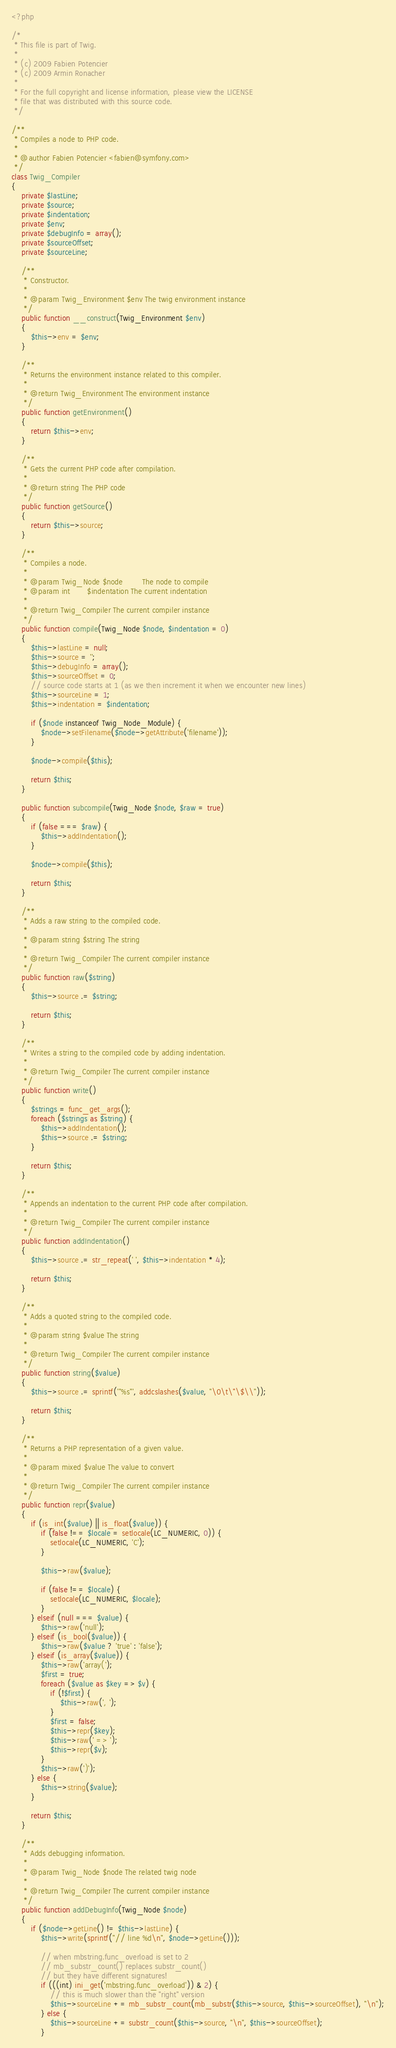<code> <loc_0><loc_0><loc_500><loc_500><_PHP_><?php

/*
 * This file is part of Twig.
 *
 * (c) 2009 Fabien Potencier
 * (c) 2009 Armin Ronacher
 *
 * For the full copyright and license information, please view the LICENSE
 * file that was distributed with this source code.
 */

/**
 * Compiles a node to PHP code.
 *
 * @author Fabien Potencier <fabien@symfony.com>
 */
class Twig_Compiler
{
    private $lastLine;
    private $source;
    private $indentation;
    private $env;
    private $debugInfo = array();
    private $sourceOffset;
    private $sourceLine;

    /**
     * Constructor.
     *
     * @param Twig_Environment $env The twig environment instance
     */
    public function __construct(Twig_Environment $env)
    {
        $this->env = $env;
    }

    /**
     * Returns the environment instance related to this compiler.
     *
     * @return Twig_Environment The environment instance
     */
    public function getEnvironment()
    {
        return $this->env;
    }

    /**
     * Gets the current PHP code after compilation.
     *
     * @return string The PHP code
     */
    public function getSource()
    {
        return $this->source;
    }

    /**
     * Compiles a node.
     *
     * @param Twig_Node $node        The node to compile
     * @param int       $indentation The current indentation
     *
     * @return Twig_Compiler The current compiler instance
     */
    public function compile(Twig_Node $node, $indentation = 0)
    {
        $this->lastLine = null;
        $this->source = '';
        $this->debugInfo = array();
        $this->sourceOffset = 0;
        // source code starts at 1 (as we then increment it when we encounter new lines)
        $this->sourceLine = 1;
        $this->indentation = $indentation;

        if ($node instanceof Twig_Node_Module) {
            $node->setFilename($node->getAttribute('filename'));
        }

        $node->compile($this);

        return $this;
    }

    public function subcompile(Twig_Node $node, $raw = true)
    {
        if (false === $raw) {
            $this->addIndentation();
        }

        $node->compile($this);

        return $this;
    }

    /**
     * Adds a raw string to the compiled code.
     *
     * @param string $string The string
     *
     * @return Twig_Compiler The current compiler instance
     */
    public function raw($string)
    {
        $this->source .= $string;

        return $this;
    }

    /**
     * Writes a string to the compiled code by adding indentation.
     *
     * @return Twig_Compiler The current compiler instance
     */
    public function write()
    {
        $strings = func_get_args();
        foreach ($strings as $string) {
            $this->addIndentation();
            $this->source .= $string;
        }

        return $this;
    }

    /**
     * Appends an indentation to the current PHP code after compilation.
     *
     * @return Twig_Compiler The current compiler instance
     */
    public function addIndentation()
    {
        $this->source .= str_repeat(' ', $this->indentation * 4);

        return $this;
    }

    /**
     * Adds a quoted string to the compiled code.
     *
     * @param string $value The string
     *
     * @return Twig_Compiler The current compiler instance
     */
    public function string($value)
    {
        $this->source .= sprintf('"%s"', addcslashes($value, "\0\t\"\$\\"));

        return $this;
    }

    /**
     * Returns a PHP representation of a given value.
     *
     * @param mixed $value The value to convert
     *
     * @return Twig_Compiler The current compiler instance
     */
    public function repr($value)
    {
        if (is_int($value) || is_float($value)) {
            if (false !== $locale = setlocale(LC_NUMERIC, 0)) {
                setlocale(LC_NUMERIC, 'C');
            }

            $this->raw($value);

            if (false !== $locale) {
                setlocale(LC_NUMERIC, $locale);
            }
        } elseif (null === $value) {
            $this->raw('null');
        } elseif (is_bool($value)) {
            $this->raw($value ? 'true' : 'false');
        } elseif (is_array($value)) {
            $this->raw('array(');
            $first = true;
            foreach ($value as $key => $v) {
                if (!$first) {
                    $this->raw(', ');
                }
                $first = false;
                $this->repr($key);
                $this->raw(' => ');
                $this->repr($v);
            }
            $this->raw(')');
        } else {
            $this->string($value);
        }

        return $this;
    }

    /**
     * Adds debugging information.
     *
     * @param Twig_Node $node The related twig node
     *
     * @return Twig_Compiler The current compiler instance
     */
    public function addDebugInfo(Twig_Node $node)
    {
        if ($node->getLine() != $this->lastLine) {
            $this->write(sprintf("// line %d\n", $node->getLine()));

            // when mbstring.func_overload is set to 2
            // mb_substr_count() replaces substr_count()
            // but they have different signatures!
            if (((int) ini_get('mbstring.func_overload')) & 2) {
                // this is much slower than the "right" version
                $this->sourceLine += mb_substr_count(mb_substr($this->source, $this->sourceOffset), "\n");
            } else {
                $this->sourceLine += substr_count($this->source, "\n", $this->sourceOffset);
            }</code> 